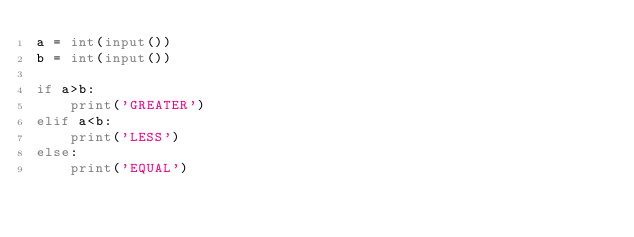Convert code to text. <code><loc_0><loc_0><loc_500><loc_500><_Python_>a = int(input())
b = int(input())

if a>b:
    print('GREATER')
elif a<b:
    print('LESS')
else:
    print('EQUAL')</code> 